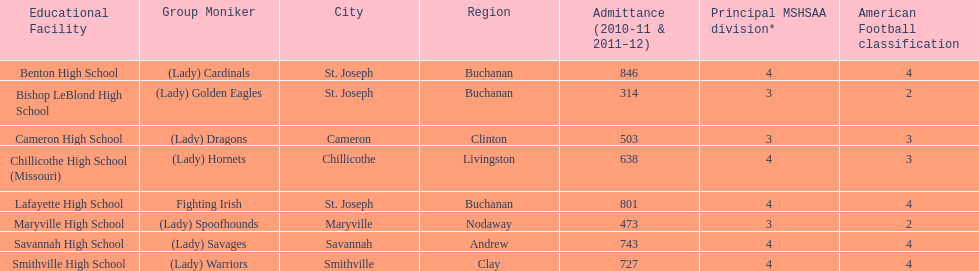Help me parse the entirety of this table. {'header': ['Educational Facility', 'Group Moniker', 'City', 'Region', 'Admittance (2010-11 & 2011–12)', 'Principal MSHSAA division*', 'American Football classification'], 'rows': [['Benton High School', '(Lady) Cardinals', 'St. Joseph', 'Buchanan', '846', '4', '4'], ['Bishop LeBlond High School', '(Lady) Golden Eagles', 'St. Joseph', 'Buchanan', '314', '3', '2'], ['Cameron High School', '(Lady) Dragons', 'Cameron', 'Clinton', '503', '3', '3'], ['Chillicothe High School (Missouri)', '(Lady) Hornets', 'Chillicothe', 'Livingston', '638', '4', '3'], ['Lafayette High School', 'Fighting Irish', 'St. Joseph', 'Buchanan', '801', '4', '4'], ['Maryville High School', '(Lady) Spoofhounds', 'Maryville', 'Nodaway', '473', '3', '2'], ['Savannah High School', '(Lady) Savages', 'Savannah', 'Andrew', '743', '4', '4'], ['Smithville High School', '(Lady) Warriors', 'Smithville', 'Clay', '727', '4', '4']]} Which school has the least amount of student enrollment between 2010-2011 and 2011-2012? Bishop LeBlond High School. 